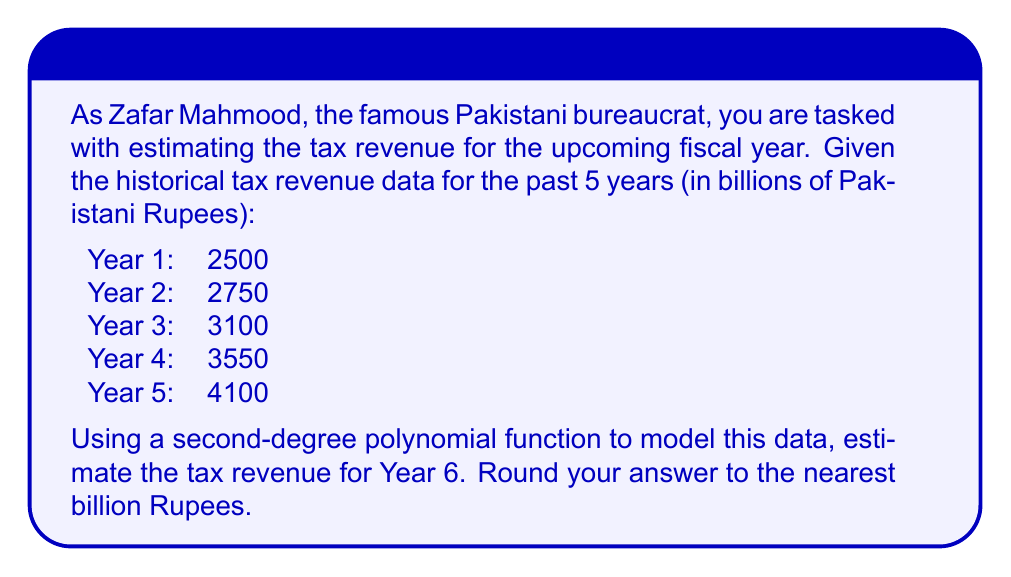Show me your answer to this math problem. To solve this problem, we'll follow these steps:

1) Let's assume our polynomial function is of the form:
   $$f(x) = ax^2 + bx + c$$
   where $x$ represents the year (with Year 1 as $x=1$, Year 2 as $x=2$, etc.) and $f(x)$ represents the tax revenue.

2) We need to find the values of $a$, $b$, and $c$ that best fit our data. We can use a system of equations:

   $$2500 = a(1)^2 + b(1) + c$$
   $$2750 = a(2)^2 + b(2) + c$$
   $$3100 = a(3)^2 + b(3) + c$$
   $$3550 = a(4)^2 + b(4) + c$$
   $$4100 = a(5)^2 + b(5) + c$$

3) Solving this system (which can be done using various methods like least squares regression) gives us:
   $$a \approx 25$$
   $$b \approx 175$$
   $$c \approx 2300$$

4) So our polynomial function is approximately:
   $$f(x) = 25x^2 + 175x + 2300$$

5) To estimate the tax revenue for Year 6, we substitute $x=6$ into our function:

   $$f(6) = 25(6)^2 + 175(6) + 2300$$
   $$    = 25(36) + 175(6) + 2300$$
   $$    = 900 + 1050 + 2300$$
   $$    = 4250$$

6) Rounding to the nearest billion gives us 4250 billion Pakistani Rupees.
Answer: The estimated tax revenue for Year 6 is 4250 billion Pakistani Rupees. 